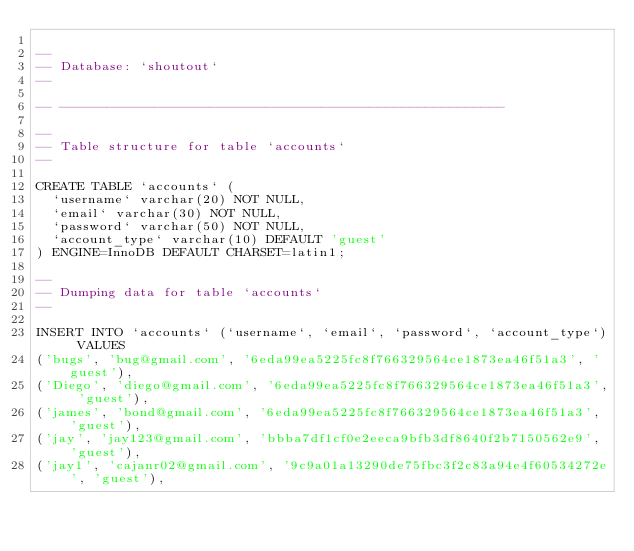<code> <loc_0><loc_0><loc_500><loc_500><_SQL_>
--
-- Database: `shoutout`
--

-- --------------------------------------------------------

--
-- Table structure for table `accounts`
--

CREATE TABLE `accounts` (
  `username` varchar(20) NOT NULL,
  `email` varchar(30) NOT NULL,
  `password` varchar(50) NOT NULL,
  `account_type` varchar(10) DEFAULT 'guest'
) ENGINE=InnoDB DEFAULT CHARSET=latin1;

--
-- Dumping data for table `accounts`
--

INSERT INTO `accounts` (`username`, `email`, `password`, `account_type`) VALUES
('bugs', 'bug@gmail.com', '6eda99ea5225fc8f766329564ce1873ea46f51a3', 'guest'),
('Diego', 'diego@gmail.com', '6eda99ea5225fc8f766329564ce1873ea46f51a3', 'guest'),
('james', 'bond@gmail.com', '6eda99ea5225fc8f766329564ce1873ea46f51a3', 'guest'),
('jay', 'jay123@gmail.com', 'bbba7df1cf0e2eeca9bfb3df8640f2b7150562e9', 'guest'),
('jay1', 'cajanr02@gmail.com', '9c9a01a13290de75fbc3f2c83a94e4f60534272e', 'guest'),</code> 